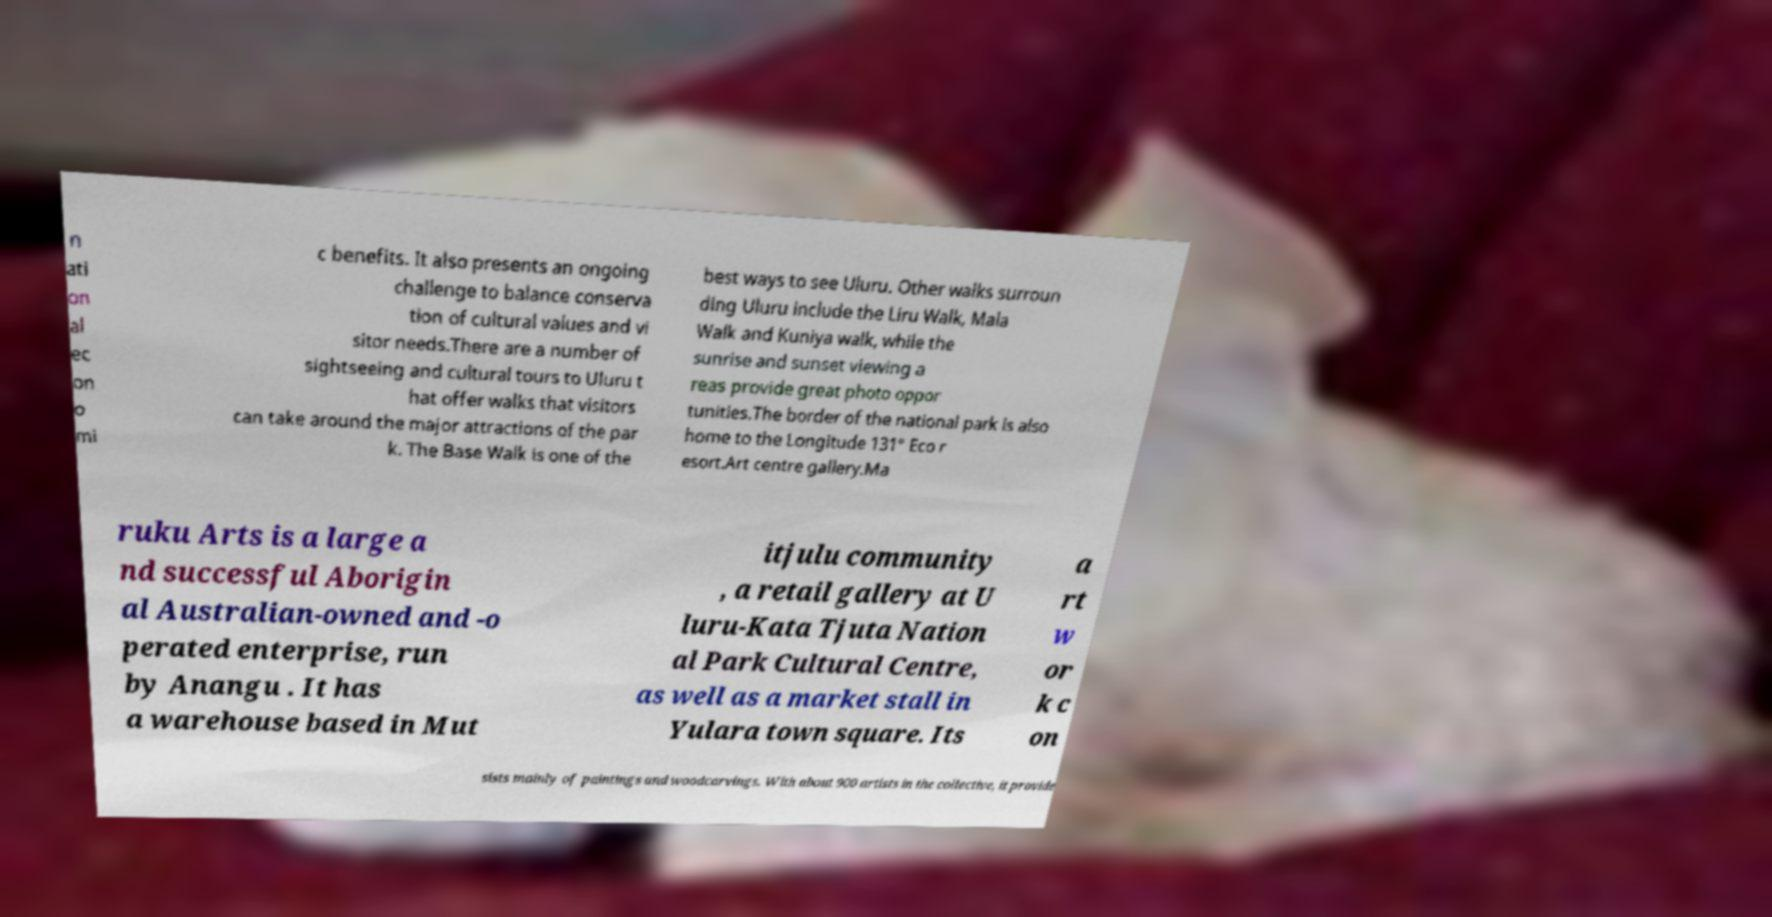For documentation purposes, I need the text within this image transcribed. Could you provide that? n ati on al ec on o mi c benefits. It also presents an ongoing challenge to balance conserva tion of cultural values and vi sitor needs.There are a number of sightseeing and cultural tours to Uluru t hat offer walks that visitors can take around the major attractions of the par k. The Base Walk is one of the best ways to see Uluru. Other walks surroun ding Uluru include the Liru Walk, Mala Walk and Kuniya walk, while the sunrise and sunset viewing a reas provide great photo oppor tunities.The border of the national park is also home to the Longitude 131° Eco r esort.Art centre gallery.Ma ruku Arts is a large a nd successful Aborigin al Australian-owned and -o perated enterprise, run by Anangu . It has a warehouse based in Mut itjulu community , a retail gallery at U luru-Kata Tjuta Nation al Park Cultural Centre, as well as a market stall in Yulara town square. Its a rt w or k c on sists mainly of paintings and woodcarvings. With about 900 artists in the collective, it provide 